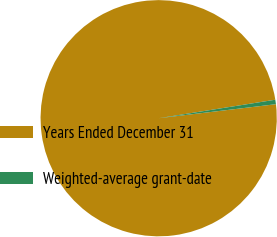Convert chart to OTSL. <chart><loc_0><loc_0><loc_500><loc_500><pie_chart><fcel>Years Ended December 31<fcel>Weighted-average grant-date<nl><fcel>99.39%<fcel>0.61%<nl></chart> 